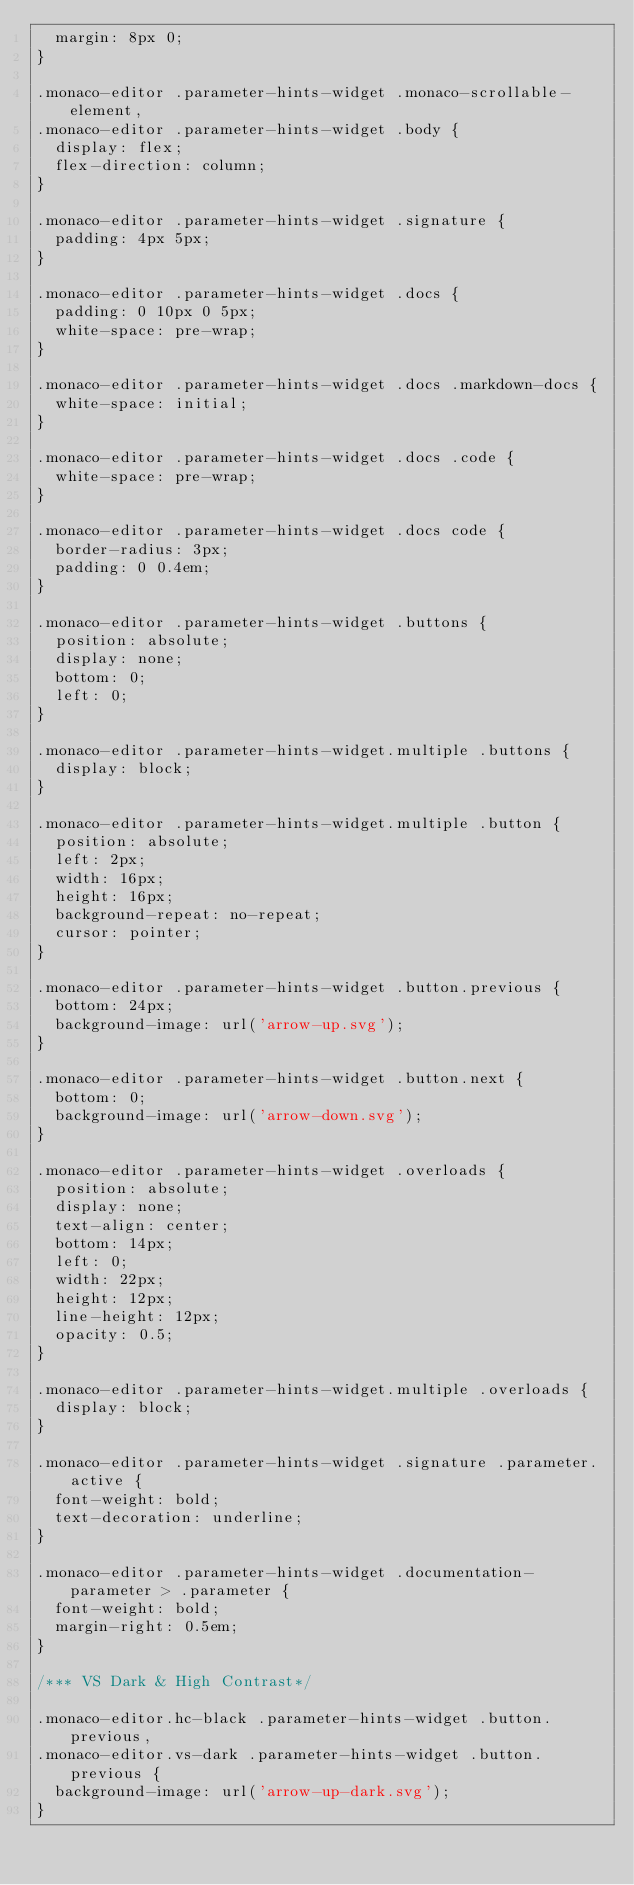<code> <loc_0><loc_0><loc_500><loc_500><_CSS_>	margin: 8px 0;
}

.monaco-editor .parameter-hints-widget .monaco-scrollable-element,
.monaco-editor .parameter-hints-widget .body {
	display: flex;
	flex-direction: column;
}

.monaco-editor .parameter-hints-widget .signature {
	padding: 4px 5px;
}

.monaco-editor .parameter-hints-widget .docs {
	padding: 0 10px 0 5px;
	white-space: pre-wrap;
}

.monaco-editor .parameter-hints-widget .docs .markdown-docs {
	white-space: initial;
}

.monaco-editor .parameter-hints-widget .docs .code {
	white-space: pre-wrap;
}

.monaco-editor .parameter-hints-widget .docs code {
	border-radius: 3px;
	padding: 0 0.4em;
}

.monaco-editor .parameter-hints-widget .buttons {
	position: absolute;
	display: none;
	bottom: 0;
	left: 0;
}

.monaco-editor .parameter-hints-widget.multiple .buttons {
	display: block;
}

.monaco-editor .parameter-hints-widget.multiple .button {
	position: absolute;
	left: 2px;
	width: 16px;
	height: 16px;
	background-repeat: no-repeat;
	cursor: pointer;
}

.monaco-editor .parameter-hints-widget .button.previous {
	bottom: 24px;
	background-image: url('arrow-up.svg');
}

.monaco-editor .parameter-hints-widget .button.next {
	bottom: 0;
	background-image: url('arrow-down.svg');
}

.monaco-editor .parameter-hints-widget .overloads {
	position: absolute;
	display: none;
	text-align: center;
	bottom: 14px;
	left: 0;
	width: 22px;
	height: 12px;
	line-height: 12px;
	opacity: 0.5;
}

.monaco-editor .parameter-hints-widget.multiple .overloads {
	display: block;
}

.monaco-editor .parameter-hints-widget .signature .parameter.active {
	font-weight: bold;
	text-decoration: underline;
}

.monaco-editor .parameter-hints-widget .documentation-parameter > .parameter {
	font-weight: bold;
	margin-right: 0.5em;
}

/*** VS Dark & High Contrast*/

.monaco-editor.hc-black .parameter-hints-widget .button.previous,
.monaco-editor.vs-dark .parameter-hints-widget .button.previous {
	background-image: url('arrow-up-dark.svg');
}
</code> 